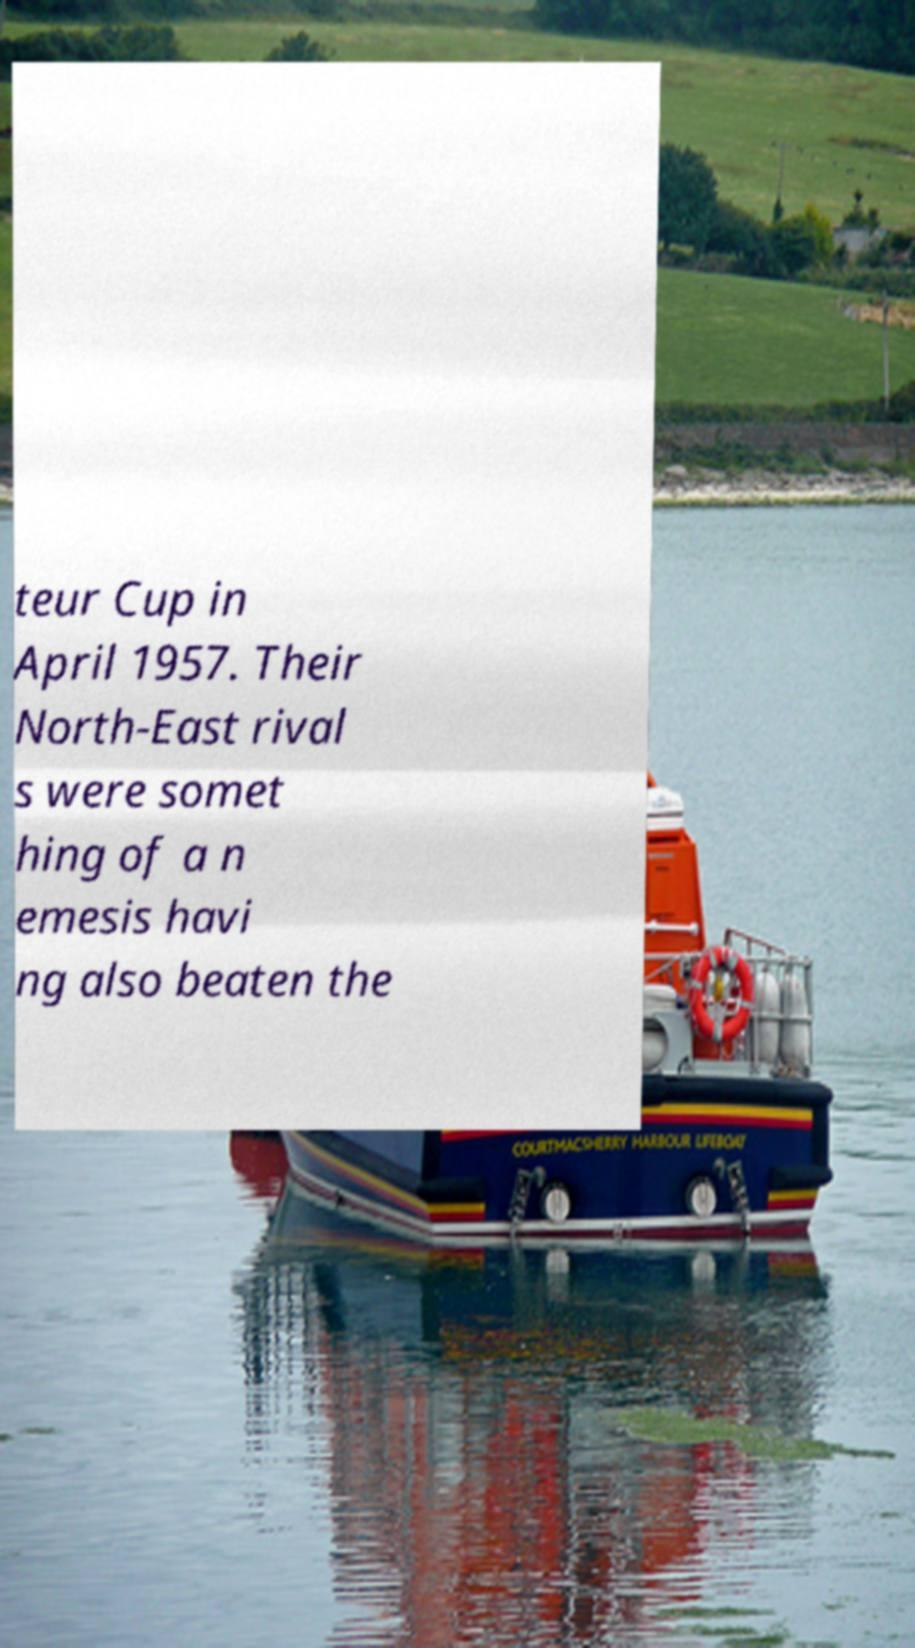Please read and relay the text visible in this image. What does it say? teur Cup in April 1957. Their North-East rival s were somet hing of a n emesis havi ng also beaten the 